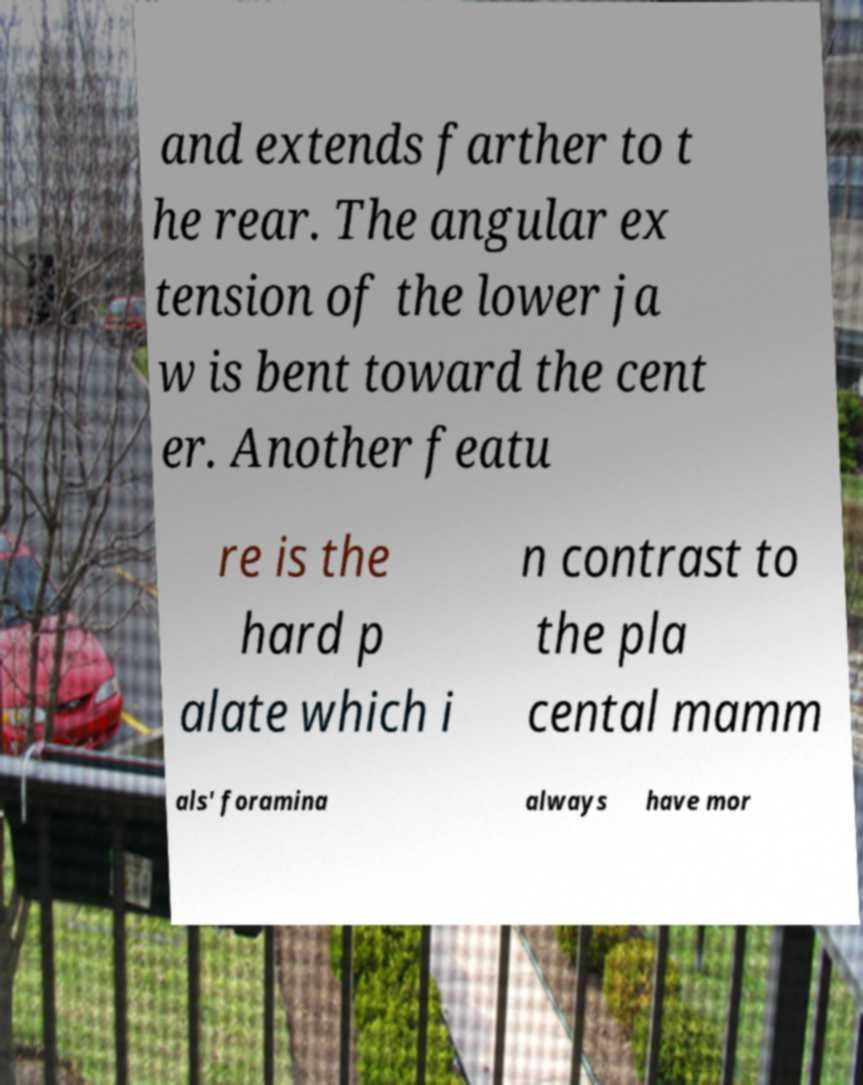Could you extract and type out the text from this image? and extends farther to t he rear. The angular ex tension of the lower ja w is bent toward the cent er. Another featu re is the hard p alate which i n contrast to the pla cental mamm als' foramina always have mor 